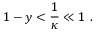Convert formula to latex. <formula><loc_0><loc_0><loc_500><loc_500>{ 1 - y } < { \frac { 1 } { \kappa } } \ll 1 \ .</formula> 